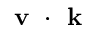Convert formula to latex. <formula><loc_0><loc_0><loc_500><loc_500>v k</formula> 